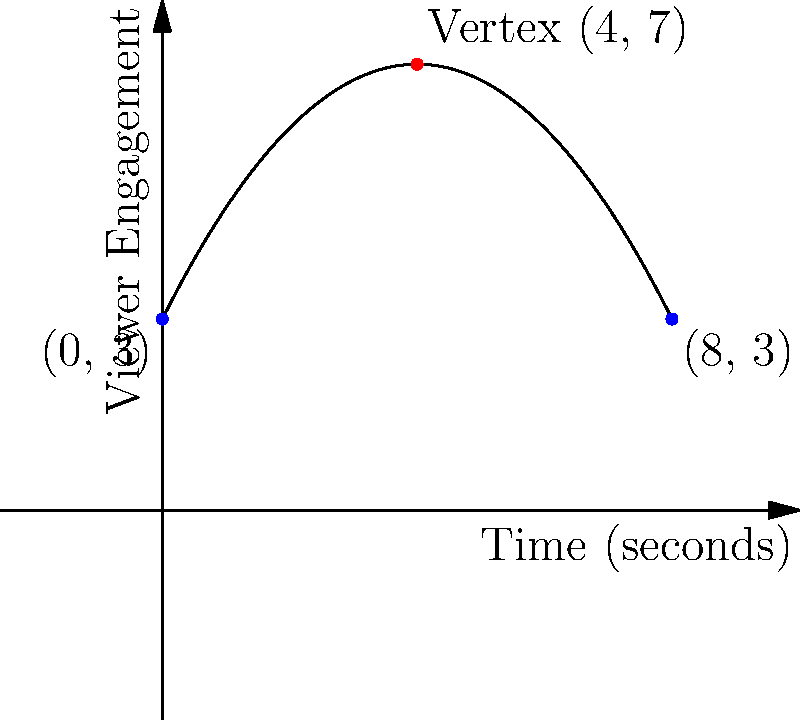A digital ad campaign's viewer engagement over time follows a parabolic curve. The engagement starts at 3 units when the ad begins, reaches a peak of 7 units after 4 seconds, and returns to 3 units after 8 seconds. Find the equation of the parabola representing viewer engagement ($y$) as a function of time ($x$) in seconds. Let's approach this step-by-step:

1) The general form of a parabola is $y = ax^2 + bx + c$.

2) We know three points on the parabola:
   (0, 3), (4, 7), and (8, 3)

3) The vertex form of a parabola is $y = a(x-h)^2 + k$, where (h,k) is the vertex.
   We know the vertex is (4, 7), so our equation becomes:
   $y = a(x-4)^2 + 7$

4) Now we can use either (0, 3) or (8, 3) to find $a$. Let's use (0, 3):
   $3 = a(0-4)^2 + 7$
   $3 = 16a + 7$
   $-4 = 16a$
   $a = -1/4 = -0.25$

5) Our equation is now:
   $y = -0.25(x-4)^2 + 7$

6) Expanding this:
   $y = -0.25(x^2 - 8x + 16) + 7$
   $y = -0.25x^2 + 2x - 4 + 7$
   $y = -0.25x^2 + 2x + 3$

7) We can verify this with the point (8, 3):
   $3 = -0.25(8^2) + 2(8) + 3$
   $3 = -16 + 16 + 3$
   $3 = 3$ (checks out)

Therefore, the equation of the parabola is $y = -0.25x^2 + 2x + 3$.
Answer: $y = -0.25x^2 + 2x + 3$ 